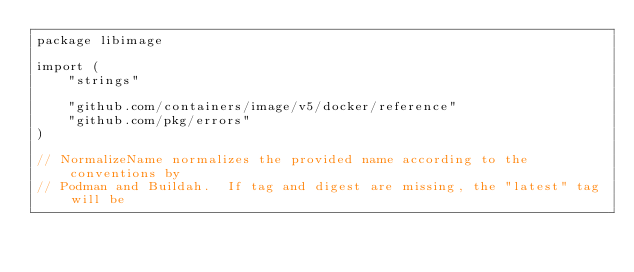<code> <loc_0><loc_0><loc_500><loc_500><_Go_>package libimage

import (
	"strings"

	"github.com/containers/image/v5/docker/reference"
	"github.com/pkg/errors"
)

// NormalizeName normalizes the provided name according to the conventions by
// Podman and Buildah.  If tag and digest are missing, the "latest" tag will be</code> 